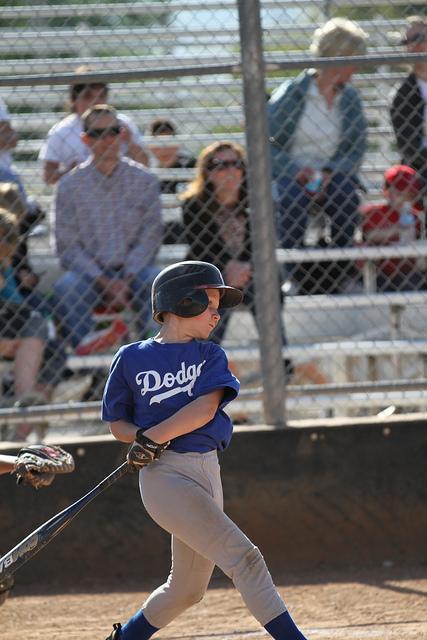How many batting helmets are in the picture?
Give a very brief answer. 1. How many people are in the picture?
Give a very brief answer. 8. How many baseball bats are in the photo?
Give a very brief answer. 1. How many benches can be seen?
Give a very brief answer. 5. How many green spray bottles are there?
Give a very brief answer. 0. 